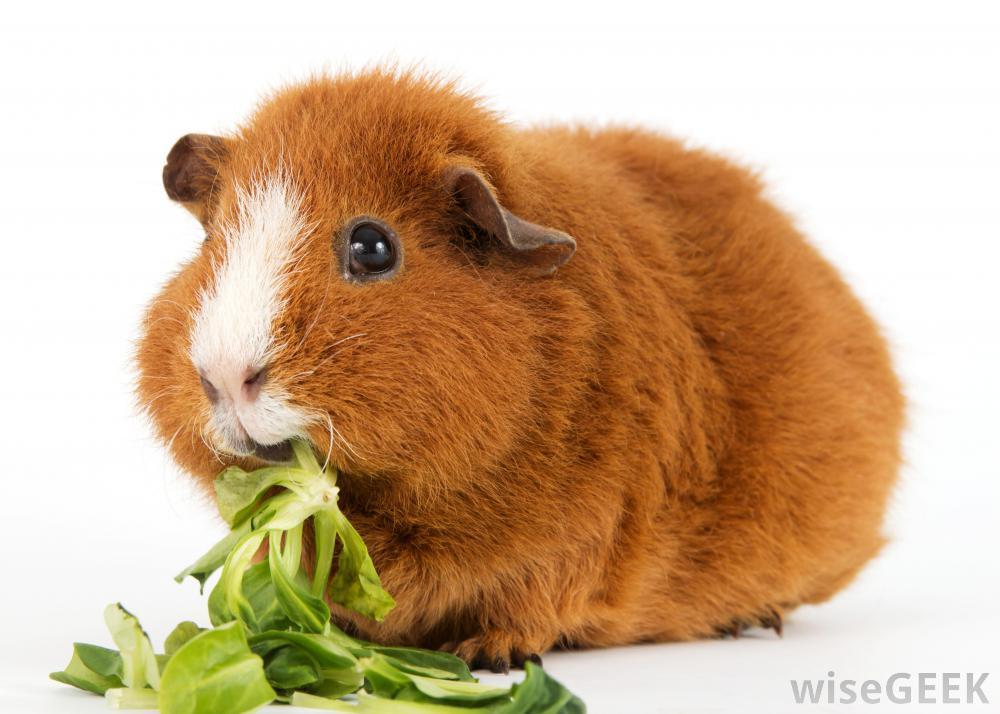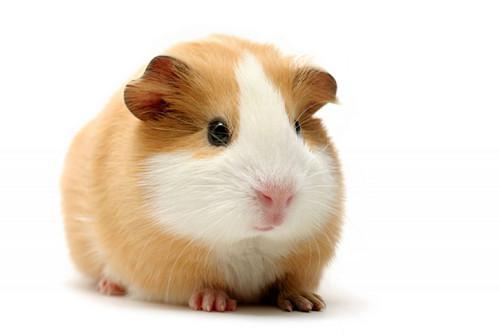The first image is the image on the left, the second image is the image on the right. Given the left and right images, does the statement "The image on the left contains food." hold true? Answer yes or no. Yes. 